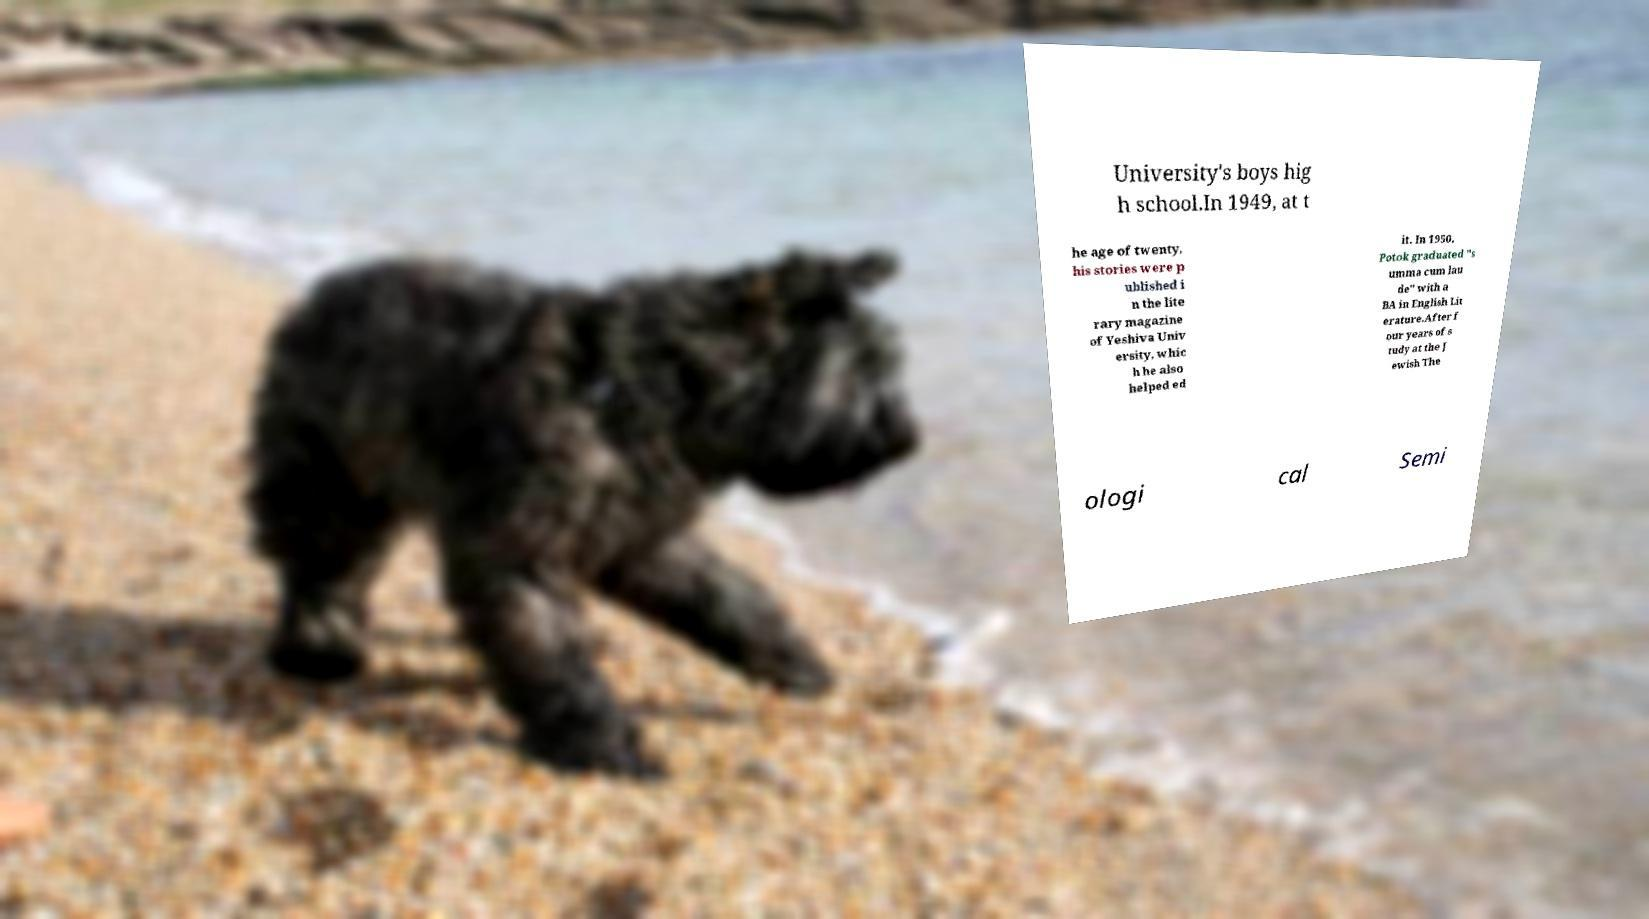There's text embedded in this image that I need extracted. Can you transcribe it verbatim? University's boys hig h school.In 1949, at t he age of twenty, his stories were p ublished i n the lite rary magazine of Yeshiva Univ ersity, whic h he also helped ed it. In 1950, Potok graduated "s umma cum lau de" with a BA in English Lit erature.After f our years of s tudy at the J ewish The ologi cal Semi 